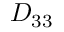<formula> <loc_0><loc_0><loc_500><loc_500>D _ { 3 3 }</formula> 